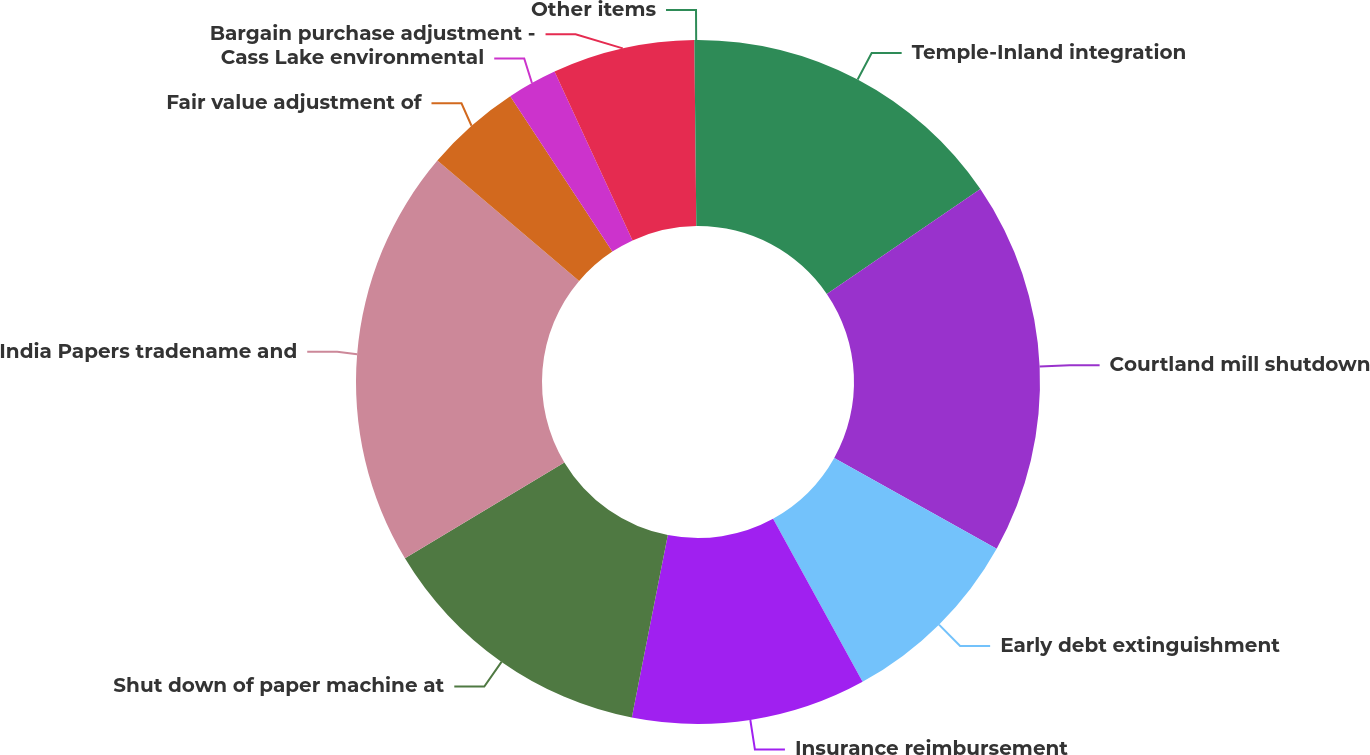Convert chart. <chart><loc_0><loc_0><loc_500><loc_500><pie_chart><fcel>Temple-Inland integration<fcel>Courtland mill shutdown<fcel>Early debt extinguishment<fcel>Insurance reimbursement<fcel>Shut down of paper machine at<fcel>India Papers tradename and<fcel>Fair value adjustment of<fcel>Cass Lake environmental<fcel>Bargain purchase adjustment -<fcel>Other items<nl><fcel>15.46%<fcel>17.64%<fcel>8.91%<fcel>11.09%<fcel>13.28%<fcel>19.83%<fcel>4.54%<fcel>2.36%<fcel>6.72%<fcel>0.17%<nl></chart> 